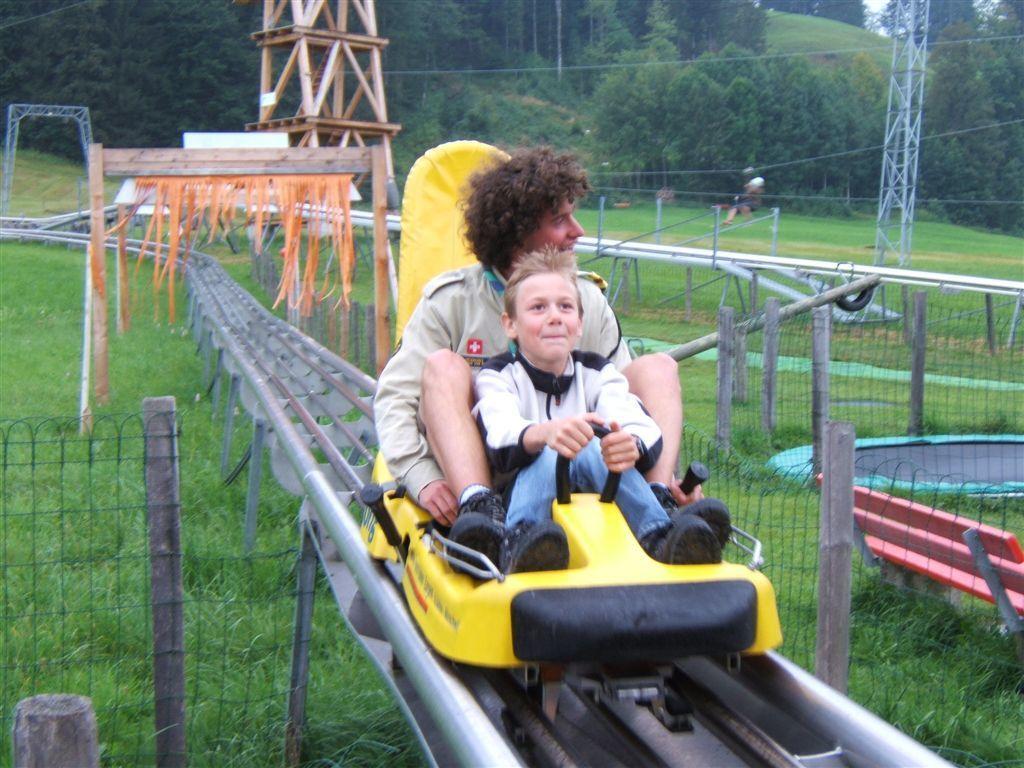Could you give a brief overview of what you see in this image? In this image I can see there are two persons visible on track and yellow color vehicle and on the left side I can see the fence and in the middle I can see cables, fence ,trees and grass. 